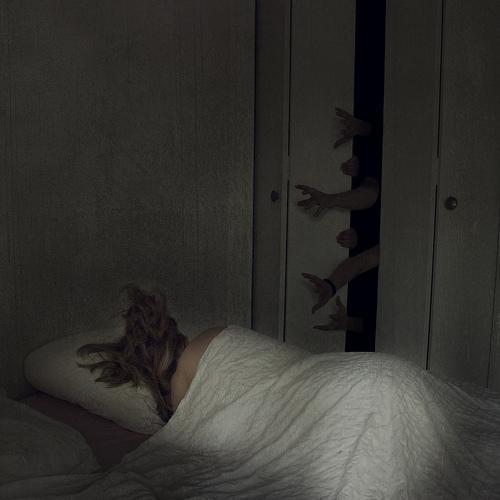How many women are there?
Give a very brief answer. 1. 